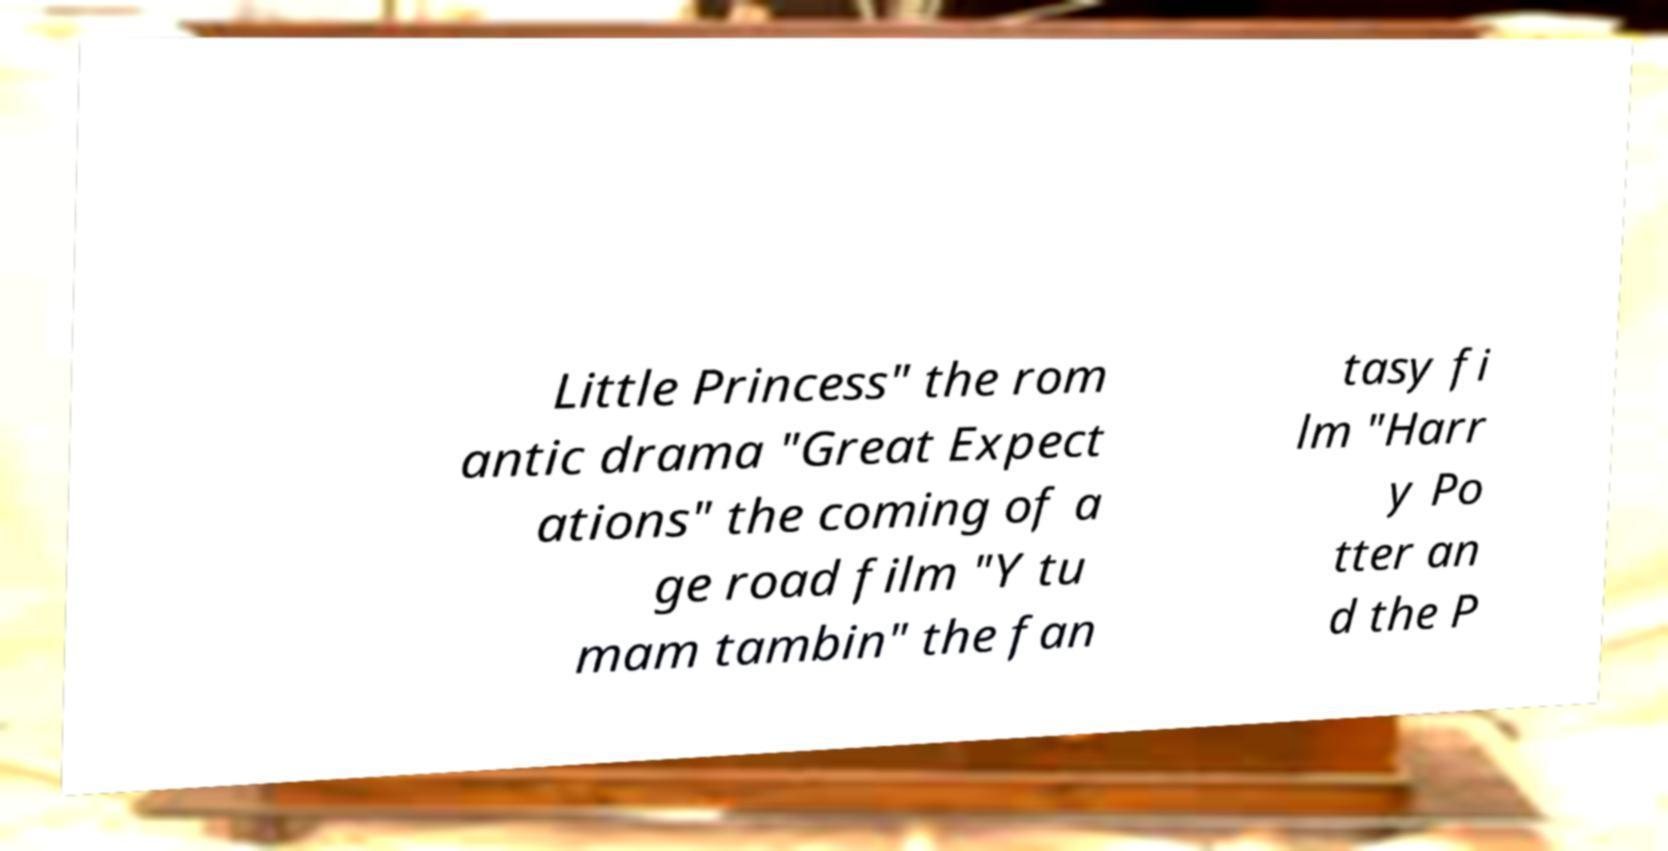Can you read and provide the text displayed in the image?This photo seems to have some interesting text. Can you extract and type it out for me? Little Princess" the rom antic drama "Great Expect ations" the coming of a ge road film "Y tu mam tambin" the fan tasy fi lm "Harr y Po tter an d the P 